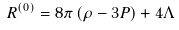Convert formula to latex. <formula><loc_0><loc_0><loc_500><loc_500>R ^ { ( 0 ) } = 8 \pi \left ( \rho - 3 P \right ) + 4 \Lambda \\</formula> 